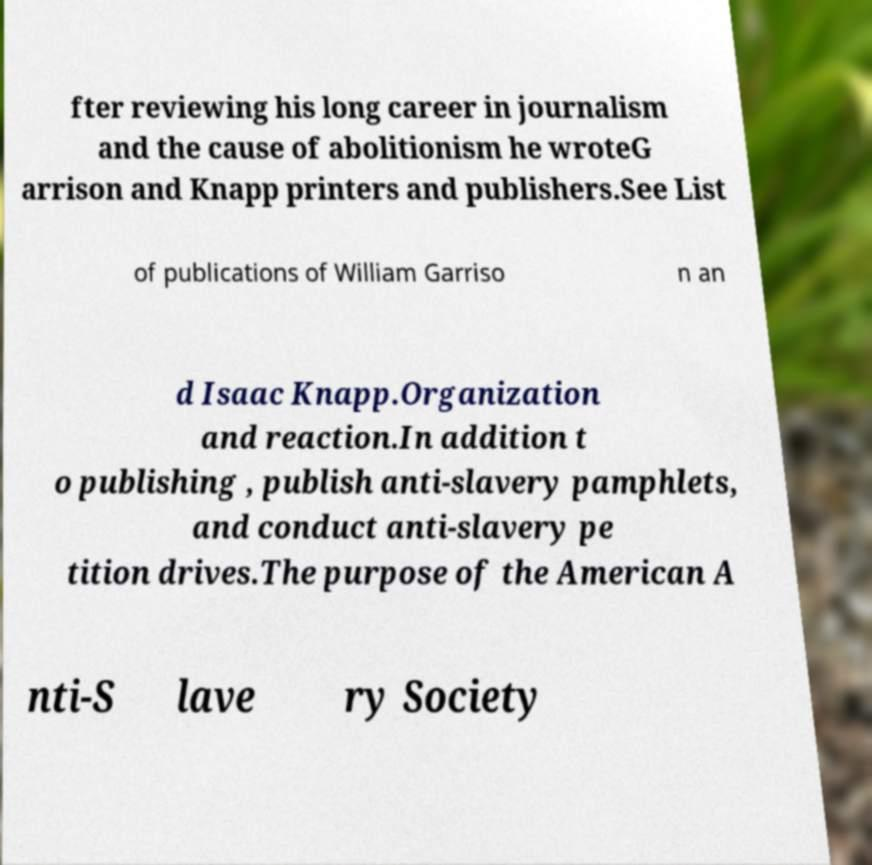Can you accurately transcribe the text from the provided image for me? fter reviewing his long career in journalism and the cause of abolitionism he wroteG arrison and Knapp printers and publishers.See List of publications of William Garriso n an d Isaac Knapp.Organization and reaction.In addition t o publishing , publish anti-slavery pamphlets, and conduct anti-slavery pe tition drives.The purpose of the American A nti-S lave ry Society 